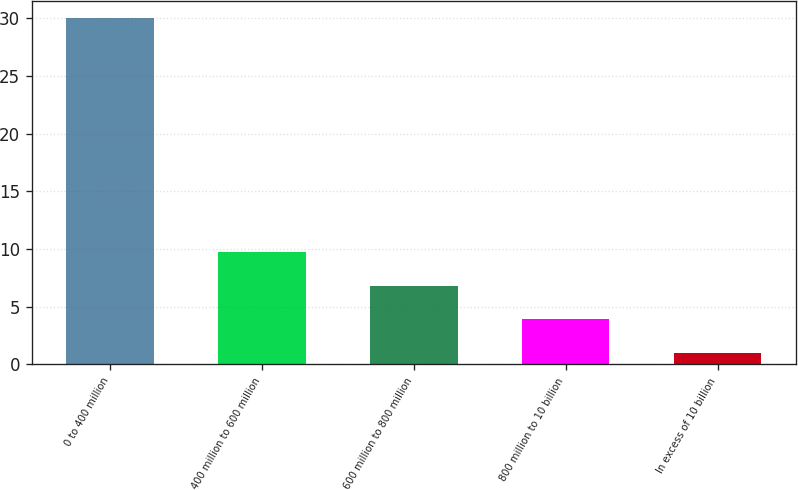Convert chart. <chart><loc_0><loc_0><loc_500><loc_500><bar_chart><fcel>0 to 400 million<fcel>400 million to 600 million<fcel>600 million to 800 million<fcel>800 million to 10 billion<fcel>In excess of 10 billion<nl><fcel>30<fcel>9.7<fcel>6.8<fcel>3.9<fcel>1<nl></chart> 